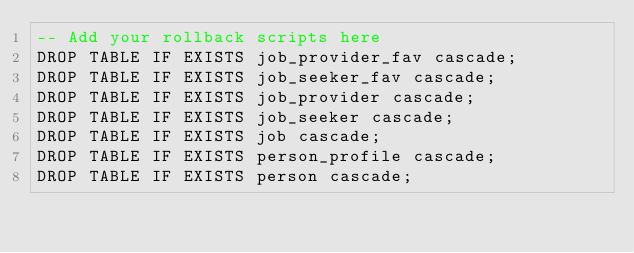Convert code to text. <code><loc_0><loc_0><loc_500><loc_500><_SQL_>-- Add your rollback scripts here
DROP TABLE IF EXISTS job_provider_fav cascade;
DROP TABLE IF EXISTS job_seeker_fav cascade;
DROP TABLE IF EXISTS job_provider cascade;
DROP TABLE IF EXISTS job_seeker cascade;
DROP TABLE IF EXISTS job cascade;
DROP TABLE IF EXISTS person_profile cascade;
DROP TABLE IF EXISTS person cascade;</code> 